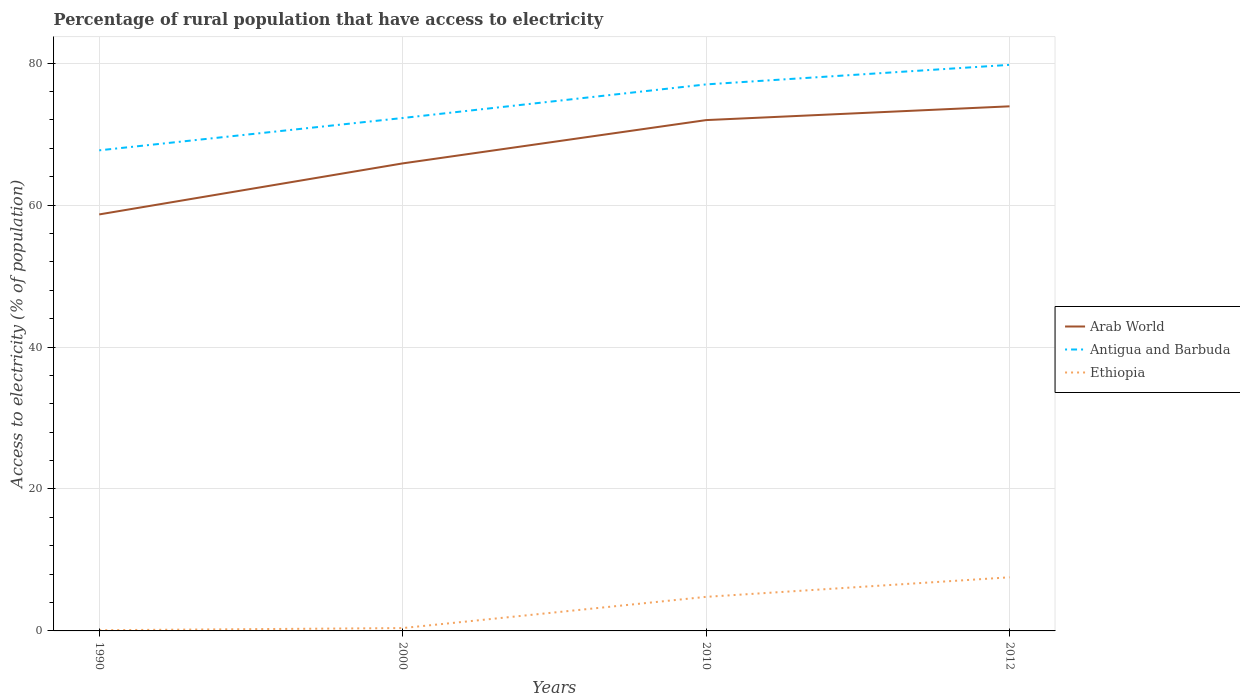How many different coloured lines are there?
Offer a terse response. 3. Across all years, what is the maximum percentage of rural population that have access to electricity in Antigua and Barbuda?
Your response must be concise. 67.71. What is the total percentage of rural population that have access to electricity in Antigua and Barbuda in the graph?
Give a very brief answer. -2.75. What is the difference between the highest and the second highest percentage of rural population that have access to electricity in Arab World?
Offer a terse response. 15.23. What is the difference between the highest and the lowest percentage of rural population that have access to electricity in Arab World?
Offer a very short reply. 2. How many lines are there?
Your answer should be very brief. 3. How many years are there in the graph?
Provide a short and direct response. 4. What is the difference between two consecutive major ticks on the Y-axis?
Give a very brief answer. 20. Where does the legend appear in the graph?
Your response must be concise. Center right. How are the legend labels stacked?
Your answer should be compact. Vertical. What is the title of the graph?
Provide a succinct answer. Percentage of rural population that have access to electricity. Does "Italy" appear as one of the legend labels in the graph?
Make the answer very short. No. What is the label or title of the Y-axis?
Your response must be concise. Access to electricity (% of population). What is the Access to electricity (% of population) of Arab World in 1990?
Provide a succinct answer. 58.68. What is the Access to electricity (% of population) of Antigua and Barbuda in 1990?
Offer a terse response. 67.71. What is the Access to electricity (% of population) of Ethiopia in 1990?
Give a very brief answer. 0.1. What is the Access to electricity (% of population) of Arab World in 2000?
Give a very brief answer. 65.87. What is the Access to electricity (% of population) of Antigua and Barbuda in 2000?
Make the answer very short. 72.27. What is the Access to electricity (% of population) in Ethiopia in 2000?
Keep it short and to the point. 0.4. What is the Access to electricity (% of population) in Arab World in 2010?
Ensure brevity in your answer.  71.97. What is the Access to electricity (% of population) in Antigua and Barbuda in 2010?
Ensure brevity in your answer.  77. What is the Access to electricity (% of population) in Ethiopia in 2010?
Provide a succinct answer. 4.8. What is the Access to electricity (% of population) of Arab World in 2012?
Make the answer very short. 73.91. What is the Access to electricity (% of population) in Antigua and Barbuda in 2012?
Make the answer very short. 79.75. What is the Access to electricity (% of population) of Ethiopia in 2012?
Your answer should be compact. 7.55. Across all years, what is the maximum Access to electricity (% of population) in Arab World?
Your response must be concise. 73.91. Across all years, what is the maximum Access to electricity (% of population) in Antigua and Barbuda?
Provide a succinct answer. 79.75. Across all years, what is the maximum Access to electricity (% of population) of Ethiopia?
Offer a terse response. 7.55. Across all years, what is the minimum Access to electricity (% of population) of Arab World?
Make the answer very short. 58.68. Across all years, what is the minimum Access to electricity (% of population) in Antigua and Barbuda?
Keep it short and to the point. 67.71. What is the total Access to electricity (% of population) in Arab World in the graph?
Keep it short and to the point. 270.43. What is the total Access to electricity (% of population) of Antigua and Barbuda in the graph?
Offer a very short reply. 296.73. What is the total Access to electricity (% of population) of Ethiopia in the graph?
Provide a succinct answer. 12.85. What is the difference between the Access to electricity (% of population) in Arab World in 1990 and that in 2000?
Your answer should be very brief. -7.19. What is the difference between the Access to electricity (% of population) in Antigua and Barbuda in 1990 and that in 2000?
Make the answer very short. -4.55. What is the difference between the Access to electricity (% of population) in Arab World in 1990 and that in 2010?
Provide a short and direct response. -13.29. What is the difference between the Access to electricity (% of population) of Antigua and Barbuda in 1990 and that in 2010?
Offer a terse response. -9.29. What is the difference between the Access to electricity (% of population) in Arab World in 1990 and that in 2012?
Give a very brief answer. -15.23. What is the difference between the Access to electricity (% of population) in Antigua and Barbuda in 1990 and that in 2012?
Give a very brief answer. -12.04. What is the difference between the Access to electricity (% of population) in Ethiopia in 1990 and that in 2012?
Provide a short and direct response. -7.45. What is the difference between the Access to electricity (% of population) of Arab World in 2000 and that in 2010?
Provide a succinct answer. -6.1. What is the difference between the Access to electricity (% of population) of Antigua and Barbuda in 2000 and that in 2010?
Provide a short and direct response. -4.74. What is the difference between the Access to electricity (% of population) of Arab World in 2000 and that in 2012?
Give a very brief answer. -8.04. What is the difference between the Access to electricity (% of population) of Antigua and Barbuda in 2000 and that in 2012?
Your answer should be very brief. -7.49. What is the difference between the Access to electricity (% of population) in Ethiopia in 2000 and that in 2012?
Your answer should be compact. -7.15. What is the difference between the Access to electricity (% of population) in Arab World in 2010 and that in 2012?
Your answer should be very brief. -1.94. What is the difference between the Access to electricity (% of population) of Antigua and Barbuda in 2010 and that in 2012?
Your answer should be compact. -2.75. What is the difference between the Access to electricity (% of population) of Ethiopia in 2010 and that in 2012?
Your answer should be very brief. -2.75. What is the difference between the Access to electricity (% of population) of Arab World in 1990 and the Access to electricity (% of population) of Antigua and Barbuda in 2000?
Make the answer very short. -13.58. What is the difference between the Access to electricity (% of population) in Arab World in 1990 and the Access to electricity (% of population) in Ethiopia in 2000?
Offer a very short reply. 58.28. What is the difference between the Access to electricity (% of population) of Antigua and Barbuda in 1990 and the Access to electricity (% of population) of Ethiopia in 2000?
Make the answer very short. 67.31. What is the difference between the Access to electricity (% of population) in Arab World in 1990 and the Access to electricity (% of population) in Antigua and Barbuda in 2010?
Keep it short and to the point. -18.32. What is the difference between the Access to electricity (% of population) in Arab World in 1990 and the Access to electricity (% of population) in Ethiopia in 2010?
Keep it short and to the point. 53.88. What is the difference between the Access to electricity (% of population) in Antigua and Barbuda in 1990 and the Access to electricity (% of population) in Ethiopia in 2010?
Your answer should be compact. 62.91. What is the difference between the Access to electricity (% of population) in Arab World in 1990 and the Access to electricity (% of population) in Antigua and Barbuda in 2012?
Offer a very short reply. -21.07. What is the difference between the Access to electricity (% of population) in Arab World in 1990 and the Access to electricity (% of population) in Ethiopia in 2012?
Your answer should be compact. 51.13. What is the difference between the Access to electricity (% of population) of Antigua and Barbuda in 1990 and the Access to electricity (% of population) of Ethiopia in 2012?
Ensure brevity in your answer.  60.16. What is the difference between the Access to electricity (% of population) in Arab World in 2000 and the Access to electricity (% of population) in Antigua and Barbuda in 2010?
Provide a succinct answer. -11.13. What is the difference between the Access to electricity (% of population) of Arab World in 2000 and the Access to electricity (% of population) of Ethiopia in 2010?
Offer a terse response. 61.07. What is the difference between the Access to electricity (% of population) of Antigua and Barbuda in 2000 and the Access to electricity (% of population) of Ethiopia in 2010?
Offer a terse response. 67.47. What is the difference between the Access to electricity (% of population) of Arab World in 2000 and the Access to electricity (% of population) of Antigua and Barbuda in 2012?
Offer a very short reply. -13.89. What is the difference between the Access to electricity (% of population) in Arab World in 2000 and the Access to electricity (% of population) in Ethiopia in 2012?
Your answer should be compact. 58.31. What is the difference between the Access to electricity (% of population) in Antigua and Barbuda in 2000 and the Access to electricity (% of population) in Ethiopia in 2012?
Keep it short and to the point. 64.71. What is the difference between the Access to electricity (% of population) of Arab World in 2010 and the Access to electricity (% of population) of Antigua and Barbuda in 2012?
Give a very brief answer. -7.78. What is the difference between the Access to electricity (% of population) in Arab World in 2010 and the Access to electricity (% of population) in Ethiopia in 2012?
Provide a short and direct response. 64.42. What is the difference between the Access to electricity (% of population) of Antigua and Barbuda in 2010 and the Access to electricity (% of population) of Ethiopia in 2012?
Provide a short and direct response. 69.45. What is the average Access to electricity (% of population) of Arab World per year?
Your response must be concise. 67.61. What is the average Access to electricity (% of population) in Antigua and Barbuda per year?
Your answer should be very brief. 74.18. What is the average Access to electricity (% of population) in Ethiopia per year?
Your answer should be very brief. 3.21. In the year 1990, what is the difference between the Access to electricity (% of population) of Arab World and Access to electricity (% of population) of Antigua and Barbuda?
Provide a short and direct response. -9.03. In the year 1990, what is the difference between the Access to electricity (% of population) of Arab World and Access to electricity (% of population) of Ethiopia?
Your answer should be compact. 58.58. In the year 1990, what is the difference between the Access to electricity (% of population) in Antigua and Barbuda and Access to electricity (% of population) in Ethiopia?
Your response must be concise. 67.61. In the year 2000, what is the difference between the Access to electricity (% of population) of Arab World and Access to electricity (% of population) of Antigua and Barbuda?
Give a very brief answer. -6.4. In the year 2000, what is the difference between the Access to electricity (% of population) of Arab World and Access to electricity (% of population) of Ethiopia?
Offer a terse response. 65.47. In the year 2000, what is the difference between the Access to electricity (% of population) in Antigua and Barbuda and Access to electricity (% of population) in Ethiopia?
Make the answer very short. 71.86. In the year 2010, what is the difference between the Access to electricity (% of population) of Arab World and Access to electricity (% of population) of Antigua and Barbuda?
Your answer should be very brief. -5.03. In the year 2010, what is the difference between the Access to electricity (% of population) of Arab World and Access to electricity (% of population) of Ethiopia?
Provide a succinct answer. 67.17. In the year 2010, what is the difference between the Access to electricity (% of population) in Antigua and Barbuda and Access to electricity (% of population) in Ethiopia?
Keep it short and to the point. 72.2. In the year 2012, what is the difference between the Access to electricity (% of population) in Arab World and Access to electricity (% of population) in Antigua and Barbuda?
Your answer should be compact. -5.84. In the year 2012, what is the difference between the Access to electricity (% of population) of Arab World and Access to electricity (% of population) of Ethiopia?
Provide a succinct answer. 66.36. In the year 2012, what is the difference between the Access to electricity (% of population) in Antigua and Barbuda and Access to electricity (% of population) in Ethiopia?
Your response must be concise. 72.2. What is the ratio of the Access to electricity (% of population) of Arab World in 1990 to that in 2000?
Make the answer very short. 0.89. What is the ratio of the Access to electricity (% of population) in Antigua and Barbuda in 1990 to that in 2000?
Provide a succinct answer. 0.94. What is the ratio of the Access to electricity (% of population) of Arab World in 1990 to that in 2010?
Provide a short and direct response. 0.82. What is the ratio of the Access to electricity (% of population) in Antigua and Barbuda in 1990 to that in 2010?
Your response must be concise. 0.88. What is the ratio of the Access to electricity (% of population) in Ethiopia in 1990 to that in 2010?
Your response must be concise. 0.02. What is the ratio of the Access to electricity (% of population) in Arab World in 1990 to that in 2012?
Provide a short and direct response. 0.79. What is the ratio of the Access to electricity (% of population) of Antigua and Barbuda in 1990 to that in 2012?
Keep it short and to the point. 0.85. What is the ratio of the Access to electricity (% of population) of Ethiopia in 1990 to that in 2012?
Make the answer very short. 0.01. What is the ratio of the Access to electricity (% of population) of Arab World in 2000 to that in 2010?
Keep it short and to the point. 0.92. What is the ratio of the Access to electricity (% of population) in Antigua and Barbuda in 2000 to that in 2010?
Ensure brevity in your answer.  0.94. What is the ratio of the Access to electricity (% of population) of Ethiopia in 2000 to that in 2010?
Offer a very short reply. 0.08. What is the ratio of the Access to electricity (% of population) of Arab World in 2000 to that in 2012?
Give a very brief answer. 0.89. What is the ratio of the Access to electricity (% of population) in Antigua and Barbuda in 2000 to that in 2012?
Make the answer very short. 0.91. What is the ratio of the Access to electricity (% of population) of Ethiopia in 2000 to that in 2012?
Your answer should be compact. 0.05. What is the ratio of the Access to electricity (% of population) in Arab World in 2010 to that in 2012?
Offer a terse response. 0.97. What is the ratio of the Access to electricity (% of population) of Antigua and Barbuda in 2010 to that in 2012?
Offer a terse response. 0.97. What is the ratio of the Access to electricity (% of population) in Ethiopia in 2010 to that in 2012?
Your response must be concise. 0.64. What is the difference between the highest and the second highest Access to electricity (% of population) of Arab World?
Your answer should be compact. 1.94. What is the difference between the highest and the second highest Access to electricity (% of population) of Antigua and Barbuda?
Keep it short and to the point. 2.75. What is the difference between the highest and the second highest Access to electricity (% of population) of Ethiopia?
Provide a short and direct response. 2.75. What is the difference between the highest and the lowest Access to electricity (% of population) of Arab World?
Provide a succinct answer. 15.23. What is the difference between the highest and the lowest Access to electricity (% of population) of Antigua and Barbuda?
Ensure brevity in your answer.  12.04. What is the difference between the highest and the lowest Access to electricity (% of population) in Ethiopia?
Your answer should be very brief. 7.45. 